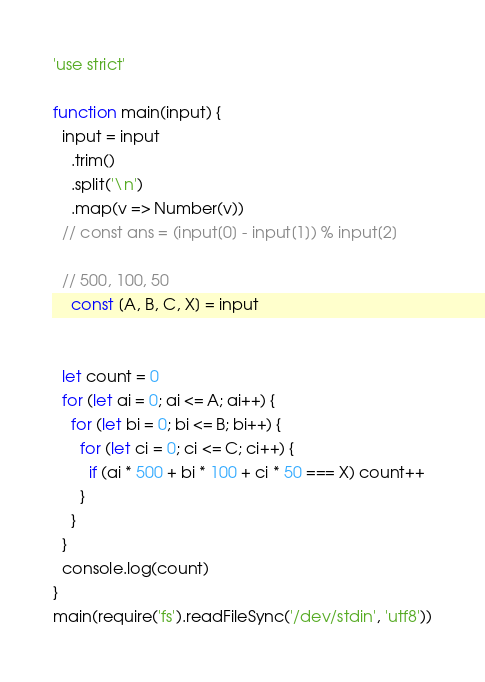<code> <loc_0><loc_0><loc_500><loc_500><_JavaScript_>'use strict'

function main(input) {
  input = input
    .trim()
    .split('\n')
    .map(v => Number(v))
  // const ans = (input[0] - input[1]) % input[2]

  // 500, 100, 50
    const [A, B, C, X] = input


  let count = 0
  for (let ai = 0; ai <= A; ai++) {
    for (let bi = 0; bi <= B; bi++) {
      for (let ci = 0; ci <= C; ci++) {
        if (ai * 500 + bi * 100 + ci * 50 === X) count++
      }
    }
  }
  console.log(count)
}
main(require('fs').readFileSync('/dev/stdin', 'utf8'))
</code> 